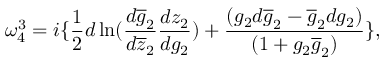<formula> <loc_0><loc_0><loc_500><loc_500>\omega _ { 4 } ^ { 3 } = i \{ \frac { 1 } { 2 } d \ln ( \frac { d \overline { g } _ { 2 } } { d \overline { z } _ { 2 } } \frac { d z _ { 2 } } { d g _ { 2 } } ) + \frac { ( g _ { 2 } d \overline { g } _ { 2 } - \overline { g } _ { 2 } d g _ { 2 } ) } { ( 1 + g _ { 2 } \overline { g } _ { 2 } ) } \} ,</formula> 